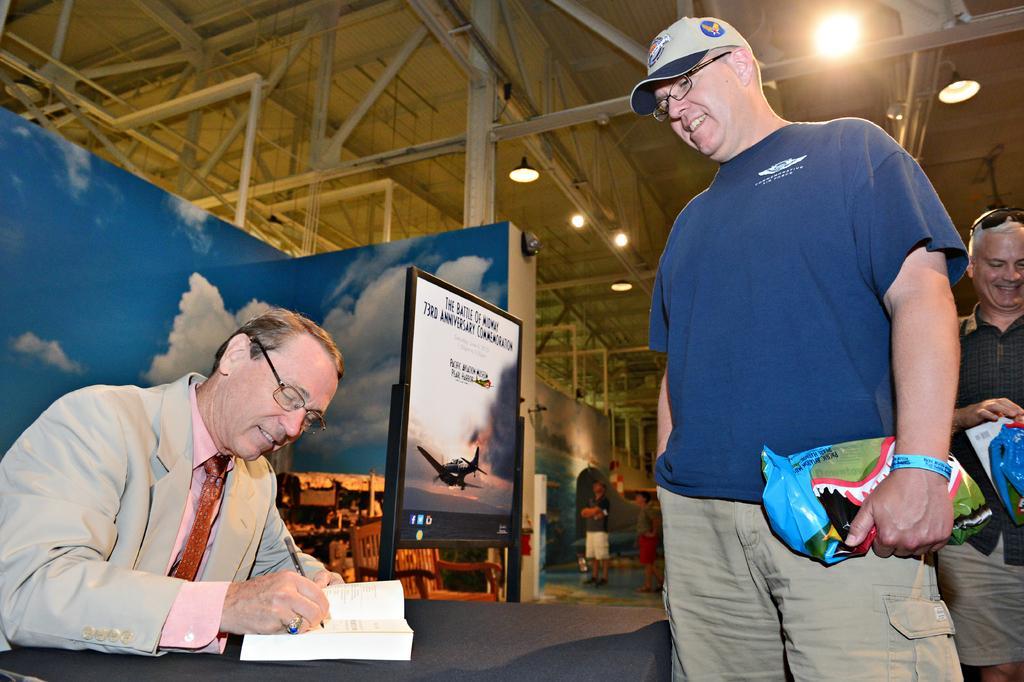Could you give a brief overview of what you see in this image? In this image we can see a person sitting and wearing a specs. He is holding a pen and writing on a book. There are two persons standing and holding something in the hand. One person is wearing specs and cap. Another person is wearing goggles on the head. In the back we can see a board with text and image of aircraft. Also there is board with painting of sky with clouds. In the back we can see chair. Also we can see few people and wall with painting. On the ceiling there are lights. 